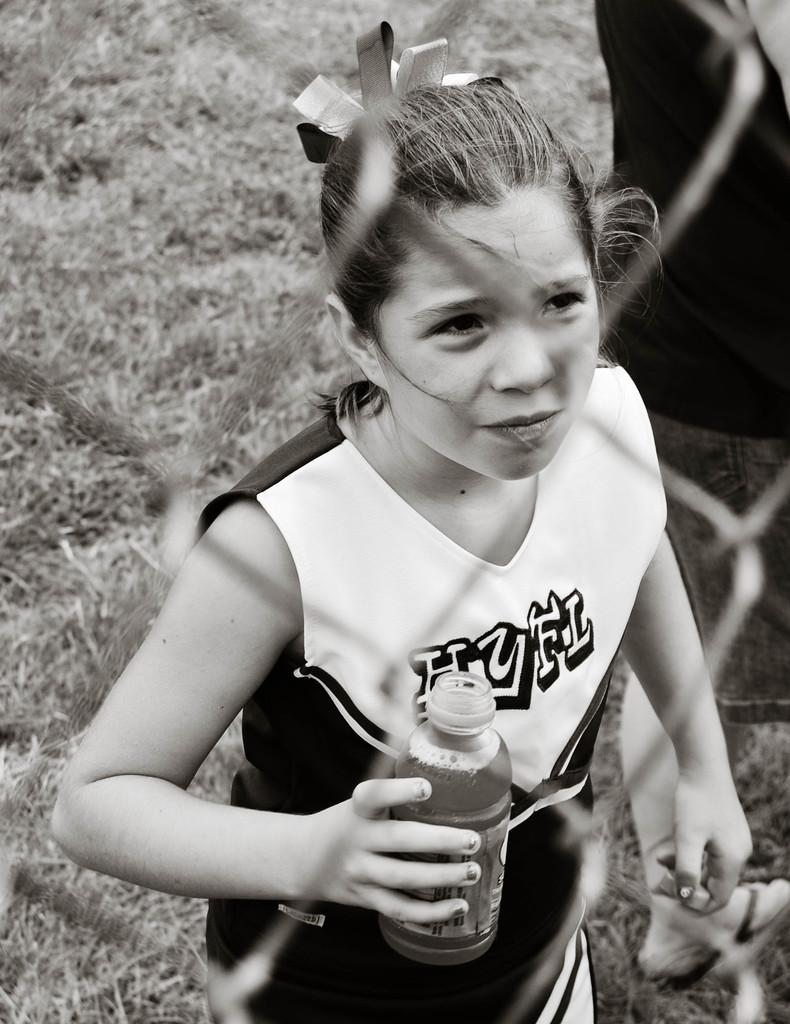Who is the main subject in the image? There is a girl in the image. What is the girl holding in the image? The girl is holding a bottle. What is in front of the girl in the image? There is a mesh in front of the girl. What type of vegetation can be seen on the ground in the image? There are grasses on the ground. What type of hair is the minister wearing in the image? There is no minister or hair present in the image; it features a girl holding a bottle with a mesh in front of her and grasses on the ground. 